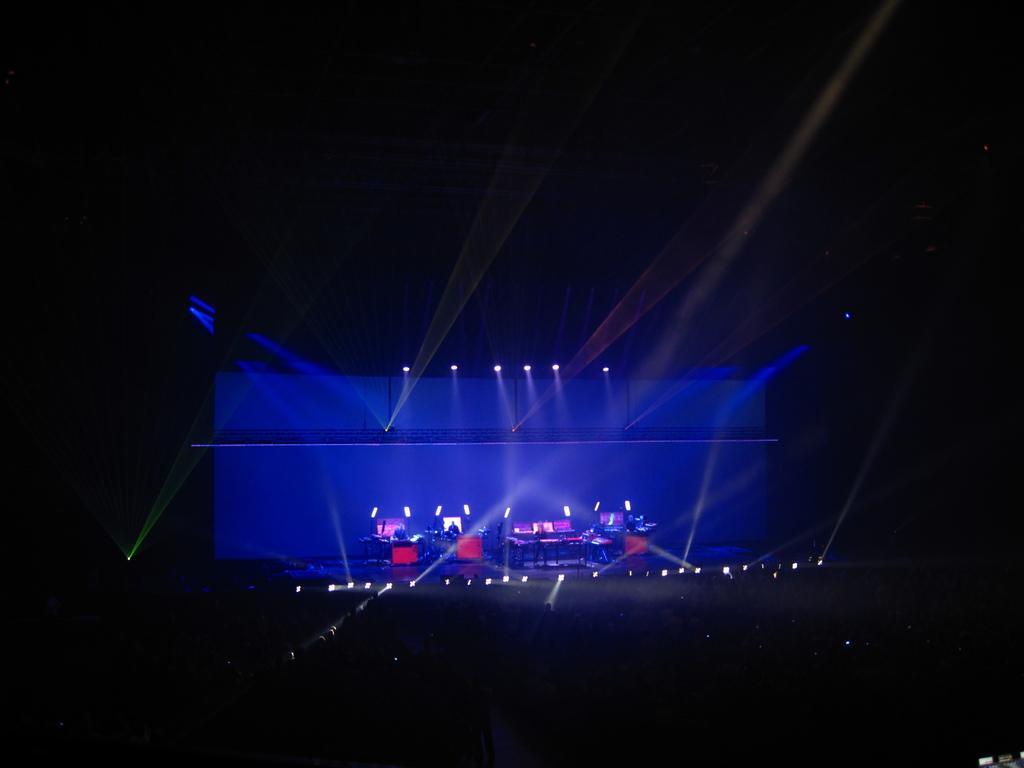Please provide a concise description of this image. This is an image clicked in the dark. In the middle of the image there is a stage on which tables and chairs are placed and also there are many lights. At the back there is a blue color board. The background is in black color. 